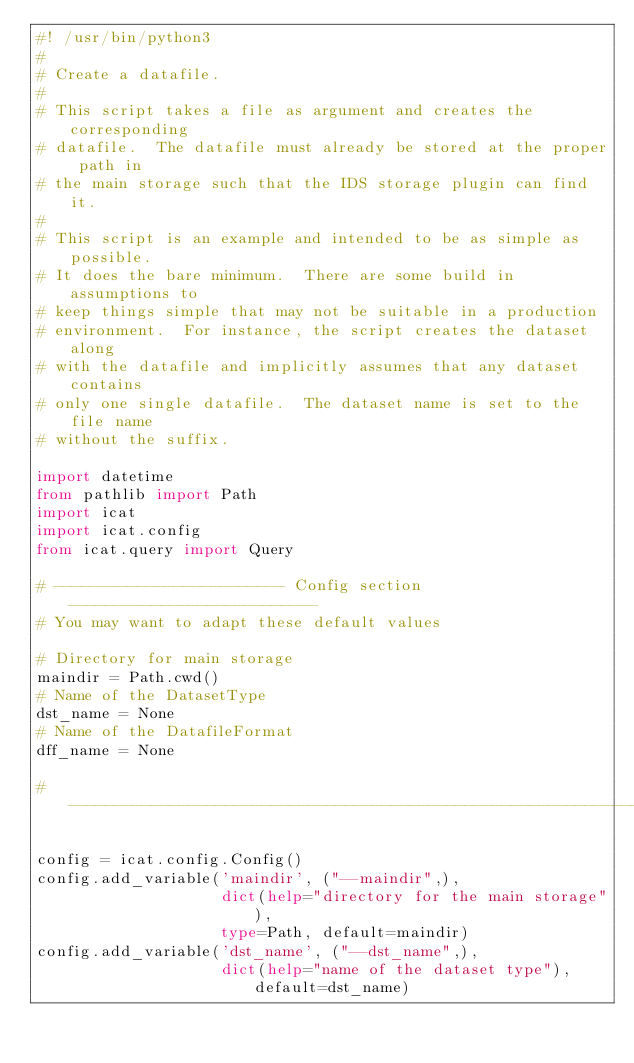Convert code to text. <code><loc_0><loc_0><loc_500><loc_500><_Python_>#! /usr/bin/python3
#
# Create a datafile.
#
# This script takes a file as argument and creates the corresponding
# datafile.  The datafile must already be stored at the proper path in
# the main storage such that the IDS storage plugin can find it.
#
# This script is an example and intended to be as simple as possible.
# It does the bare minimum.  There are some build in assumptions to
# keep things simple that may not be suitable in a production
# environment.  For instance, the script creates the dataset along
# with the datafile and implicitly assumes that any dataset contains
# only one single datafile.  The dataset name is set to the file name
# without the suffix.

import datetime
from pathlib import Path
import icat
import icat.config
from icat.query import Query

# ------------------------- Config section ---------------------------
# You may want to adapt these default values

# Directory for main storage
maindir = Path.cwd()
# Name of the DatasetType
dst_name = None
# Name of the DatafileFormat
dff_name = None

# --------------------------------------------------------------------

config = icat.config.Config()
config.add_variable('maindir', ("--maindir",),
                    dict(help="directory for the main storage"),
                    type=Path, default=maindir)
config.add_variable('dst_name', ("--dst_name",),
                    dict(help="name of the dataset type"), default=dst_name)</code> 